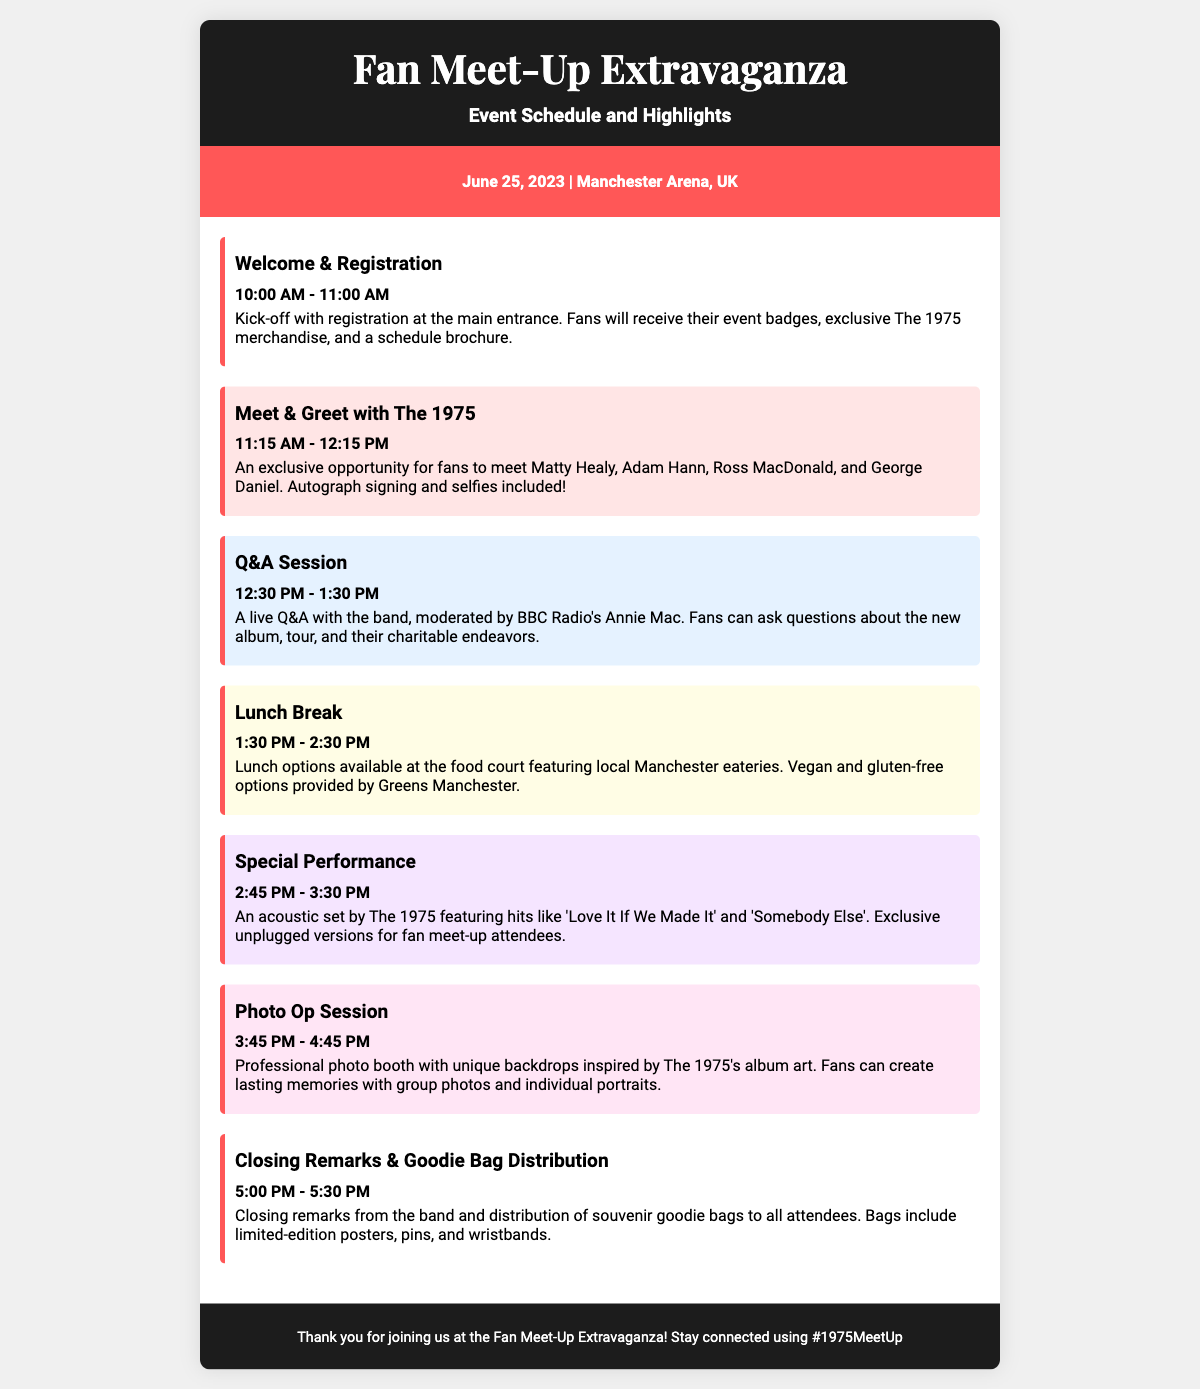What time does registration start? The registration begins at 10:00 AM as stated in the schedule item.
Answer: 10:00 AM Who is moderating the Q&A session? The document specifies that the Q&A will be moderated by BBC Radio's Annie Mac.
Answer: Annie Mac What is the duration of the lunch break? The lunch break is mentioned to last for one hour, from 1:30 PM to 2:30 PM.
Answer: 1 hour What special performance will The 1975 do? The document outlines that The 1975 will perform an acoustic set featuring selected hits.
Answer: Acoustic set How many activities are there listed in the schedule? The schedule has a total of six distinct activities based on the headings provided.
Answer: Six What is included in the goodie bags? The document details that souvenir goodie bags include limited-edition posters, pins, and wristbands.
Answer: Posters, pins, and wristbands What is the location of the event? The event is stated to take place at Manchester Arena in the UK.
Answer: Manchester Arena What color is the Meet & Greet section? The styling in the document shows that the Meet & Greet section is highlighted with a light pink background.
Answer: Light pink 